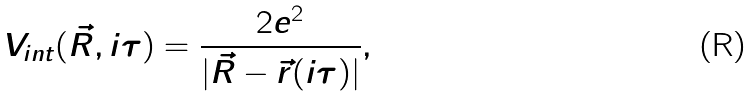<formula> <loc_0><loc_0><loc_500><loc_500>V _ { i n t } ( \vec { R } , i \tau ) = \frac { 2 e ^ { 2 } } { | \vec { R } - \vec { r } ( i \tau ) | } ,</formula> 